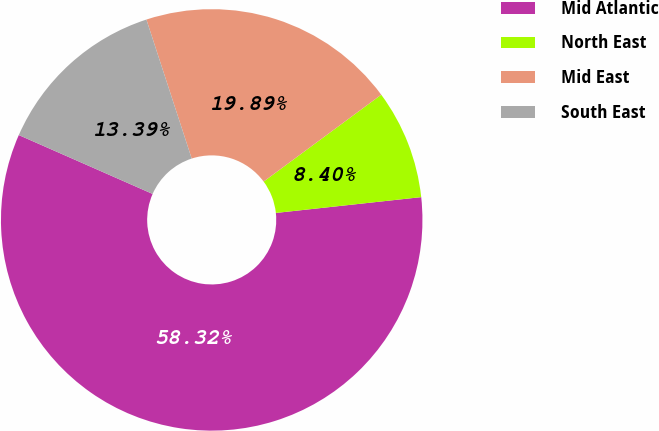<chart> <loc_0><loc_0><loc_500><loc_500><pie_chart><fcel>Mid Atlantic<fcel>North East<fcel>Mid East<fcel>South East<nl><fcel>58.32%<fcel>8.4%<fcel>19.89%<fcel>13.39%<nl></chart> 